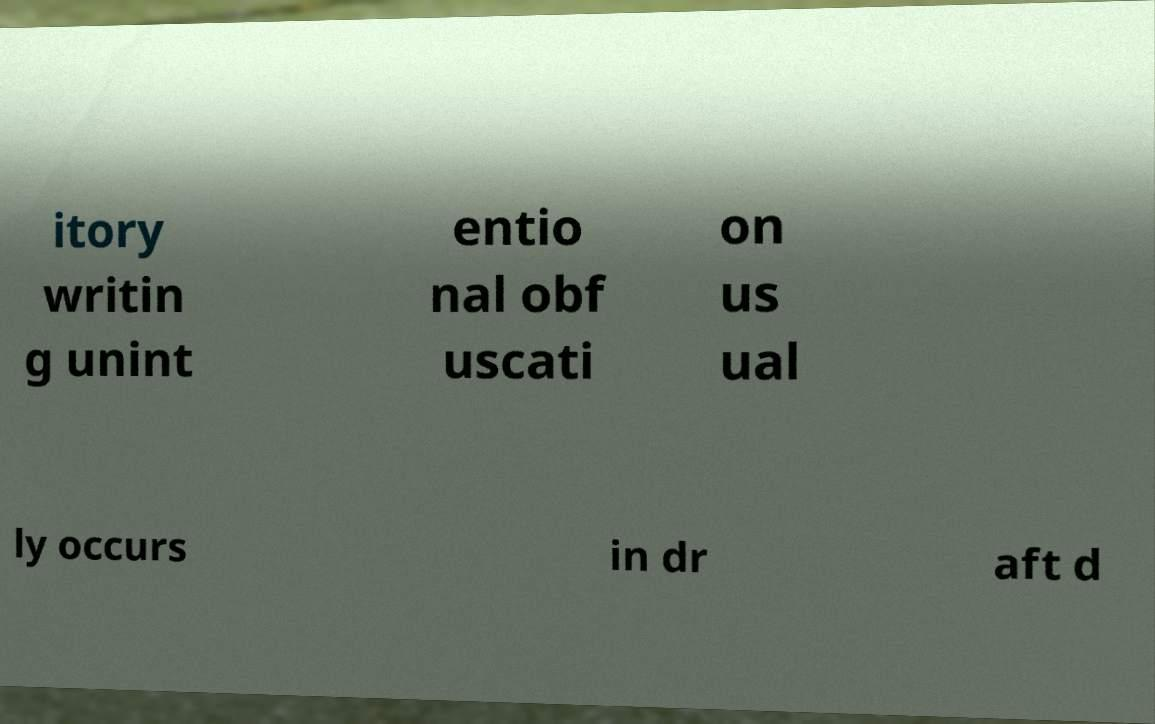Please read and relay the text visible in this image. What does it say? itory writin g unint entio nal obf uscati on us ual ly occurs in dr aft d 